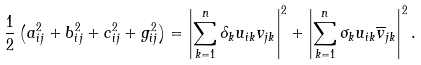Convert formula to latex. <formula><loc_0><loc_0><loc_500><loc_500>\frac { 1 } { 2 } \left ( a _ { i j } ^ { 2 } + b _ { i j } ^ { 2 } + c _ { i j } ^ { 2 } + g _ { i j } ^ { 2 } \right ) = \left | \sum _ { k = 1 } ^ { n } \delta _ { k } u _ { i k } v _ { j k } \right | ^ { 2 } + \left | \sum _ { k = 1 } ^ { n } \sigma _ { k } u _ { i k } \overline { v } _ { j k } \right | ^ { 2 } .</formula> 